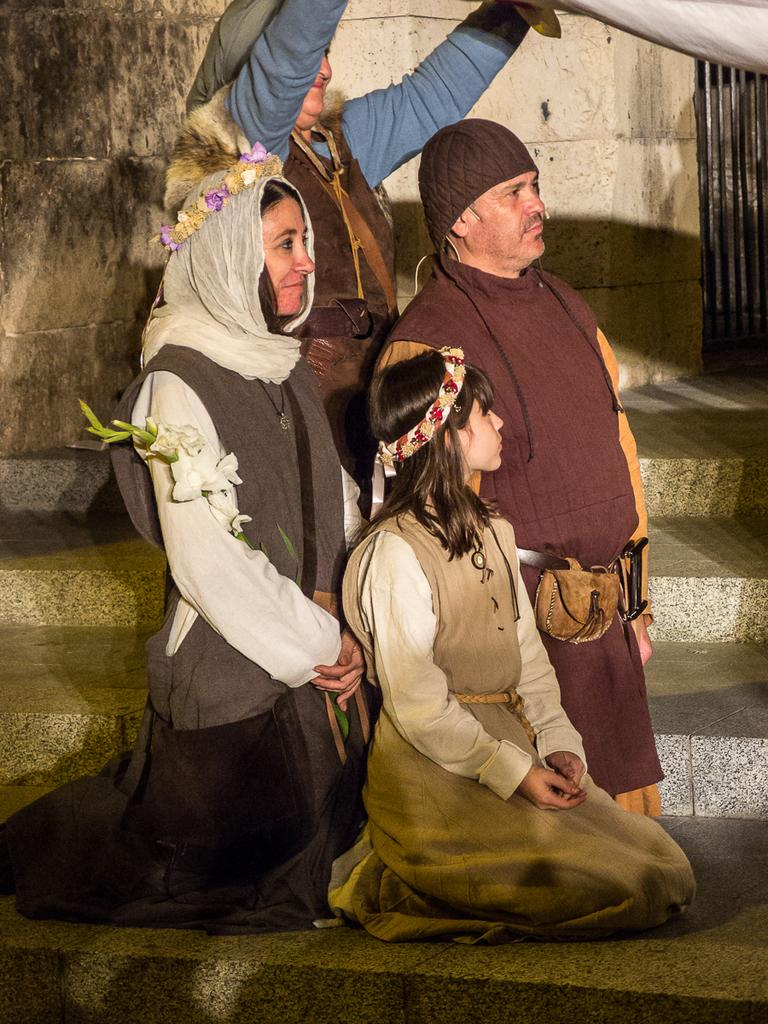What is the main subject of the image? The main subject of the image is a group of people. Where are the people located in the image? The group of people is on a staircase in the center of the image. What can be seen in the background of the image? There is a well in the background of the image. What type of store can be seen in the image? There is no store present in the image; it features a group of people on a staircase with a well in the background. Can you tell me how many quills are being used by the people in the image? There is no mention of quills in the image, so it is not possible to determine how they might be used. 